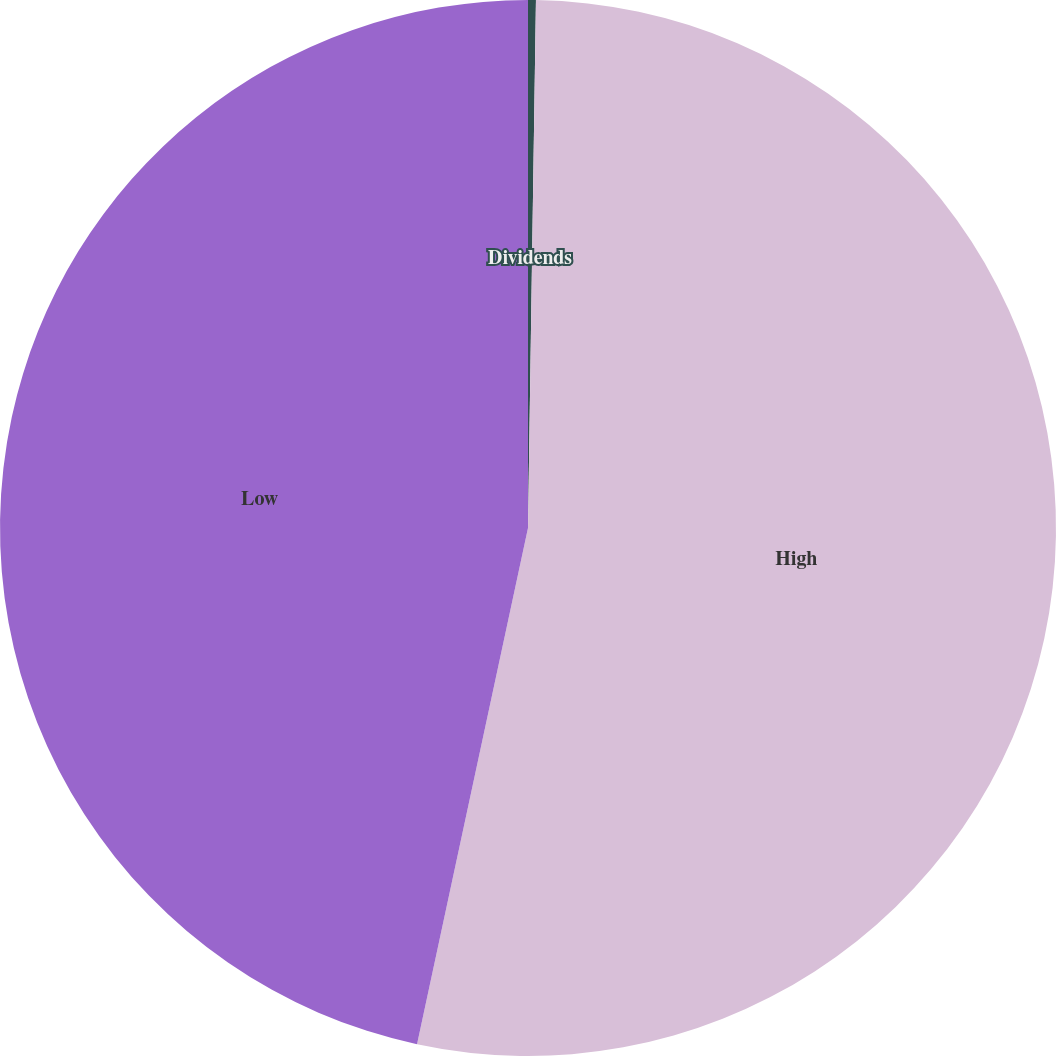Convert chart to OTSL. <chart><loc_0><loc_0><loc_500><loc_500><pie_chart><fcel>Dividends<fcel>High<fcel>Low<nl><fcel>0.24%<fcel>53.13%<fcel>46.63%<nl></chart> 